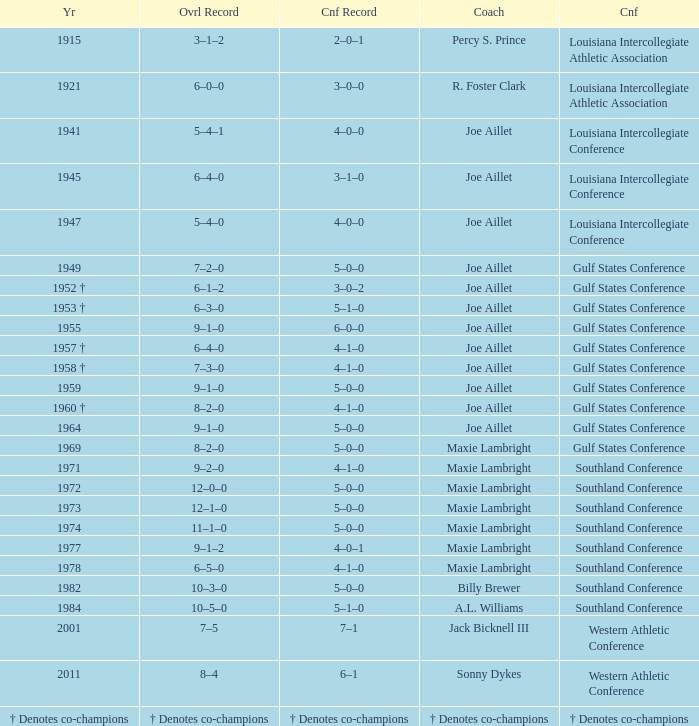What is the meeting record for the year of 1971? 4–1–0. 